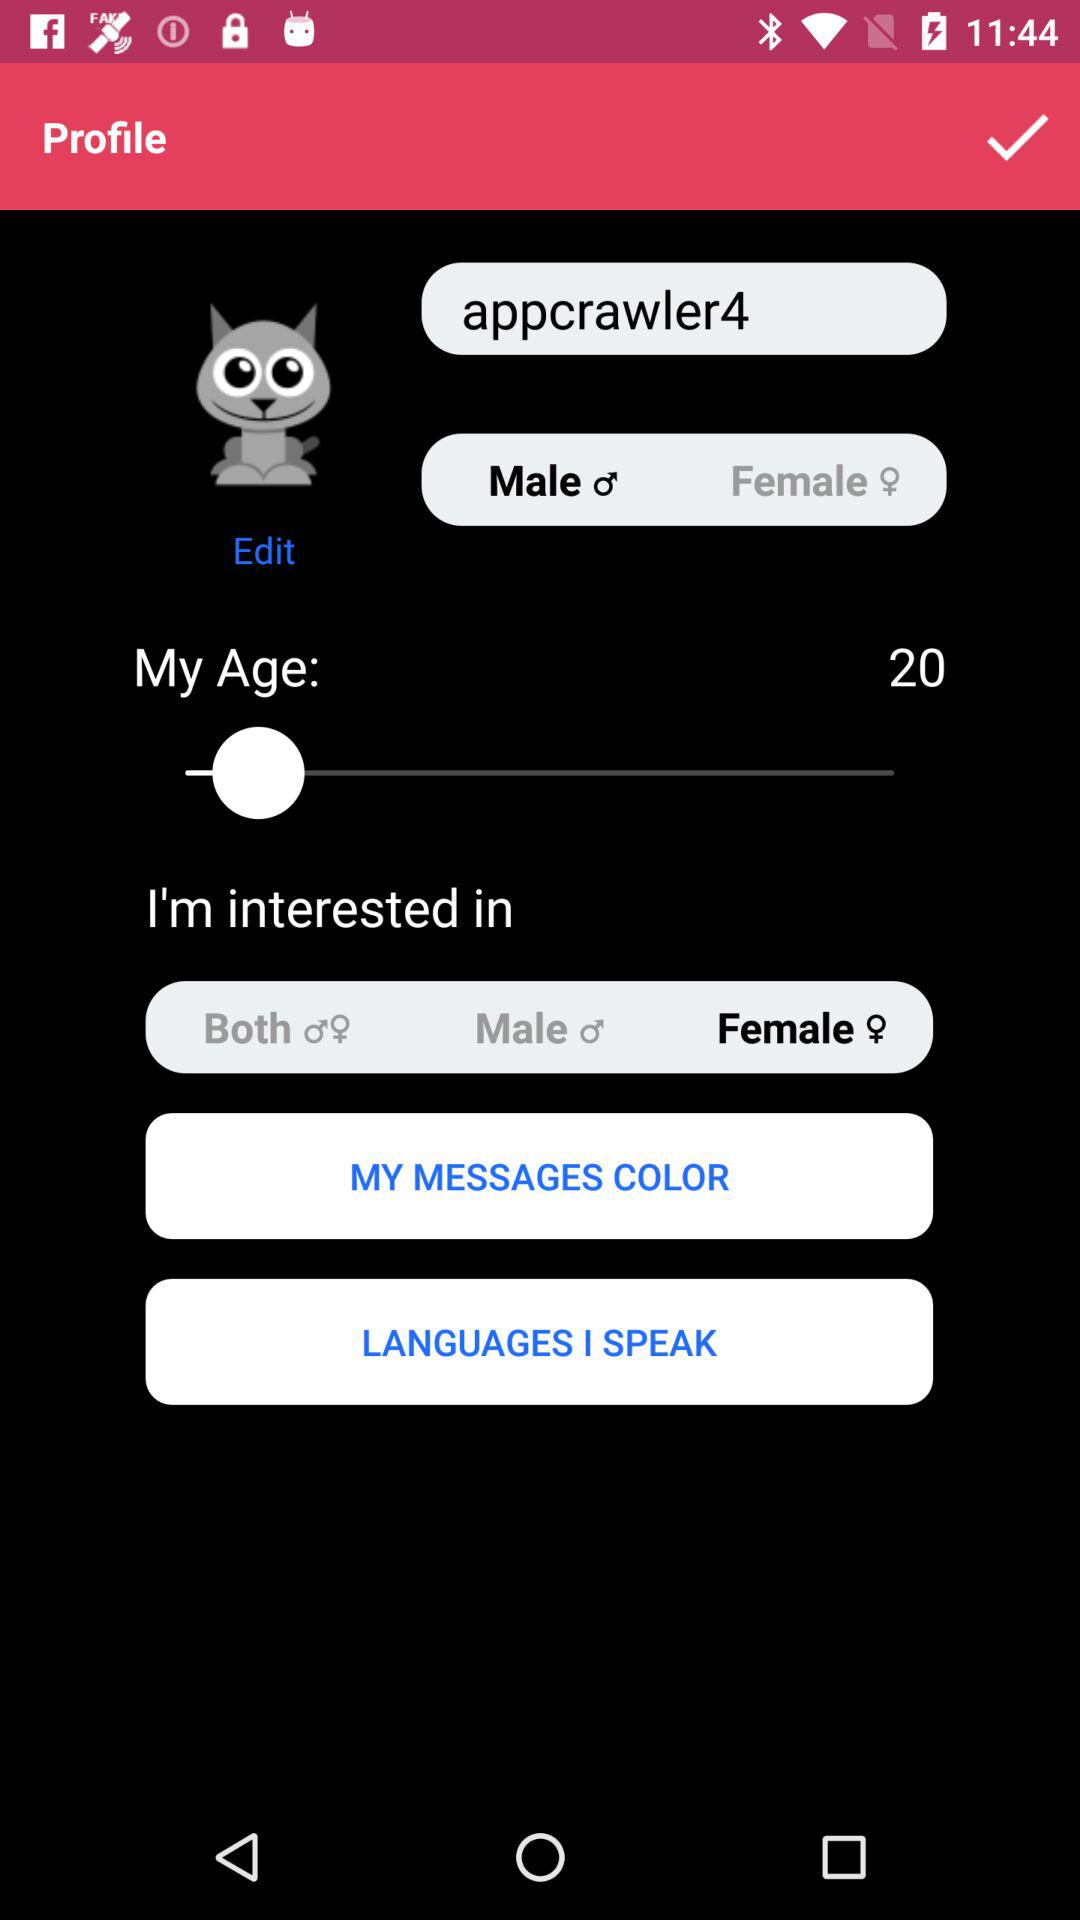In which gender is the person interested? The person is interested in a female. 